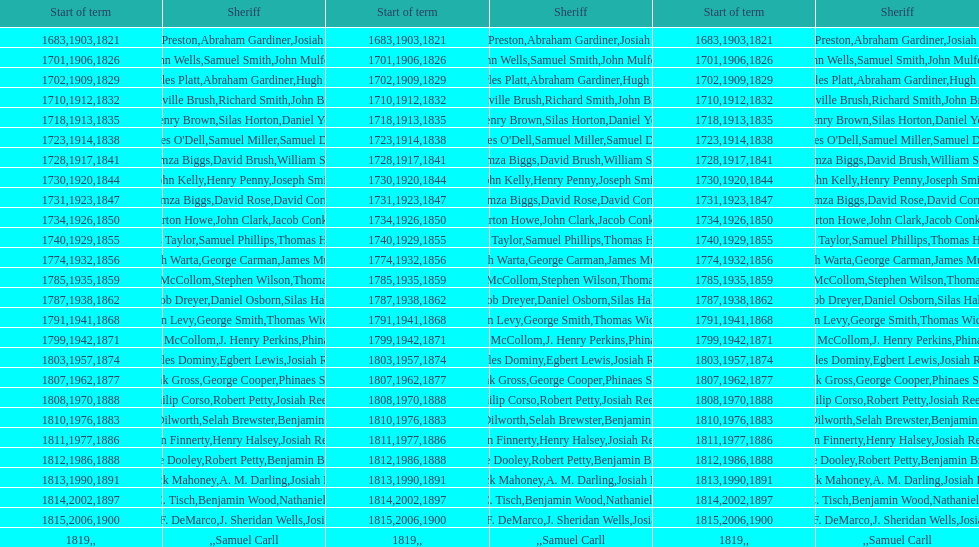How many sheriff's have the last name biggs? 1. 